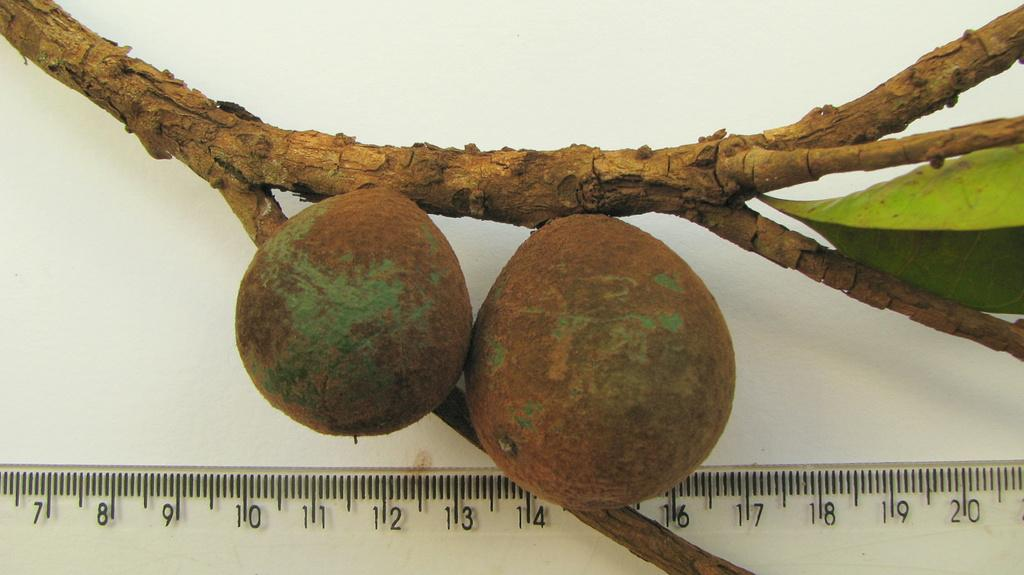<image>
Give a short and clear explanation of the subsequent image. Two green and brown pear shaped fruits attached to a limb next to clear ruler measuring 3 and 3.75 inches. 